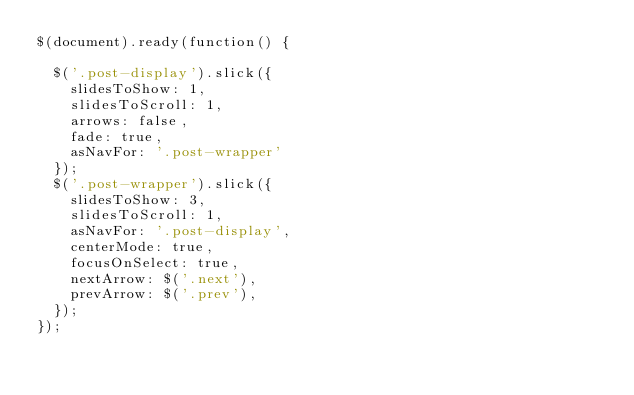Convert code to text. <code><loc_0><loc_0><loc_500><loc_500><_JavaScript_>$(document).ready(function() {
  
  $('.post-display').slick({
    slidesToShow: 1,
    slidesToScroll: 1,
    arrows: false,
    fade: true,
    asNavFor: '.post-wrapper'
  });
  $('.post-wrapper').slick({
    slidesToShow: 3,
    slidesToScroll: 1,
    asNavFor: '.post-display',
    centerMode: true,
    focusOnSelect: true,
    nextArrow: $('.next'),
    prevArrow: $('.prev'), 
  });
});</code> 